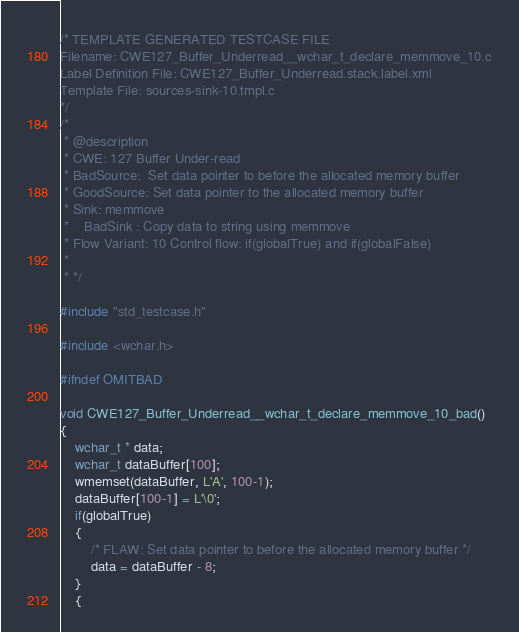Convert code to text. <code><loc_0><loc_0><loc_500><loc_500><_C_>/* TEMPLATE GENERATED TESTCASE FILE
Filename: CWE127_Buffer_Underread__wchar_t_declare_memmove_10.c
Label Definition File: CWE127_Buffer_Underread.stack.label.xml
Template File: sources-sink-10.tmpl.c
*/
/*
 * @description
 * CWE: 127 Buffer Under-read
 * BadSource:  Set data pointer to before the allocated memory buffer
 * GoodSource: Set data pointer to the allocated memory buffer
 * Sink: memmove
 *    BadSink : Copy data to string using memmove
 * Flow Variant: 10 Control flow: if(globalTrue) and if(globalFalse)
 *
 * */

#include "std_testcase.h"

#include <wchar.h>

#ifndef OMITBAD

void CWE127_Buffer_Underread__wchar_t_declare_memmove_10_bad()
{
    wchar_t * data;
    wchar_t dataBuffer[100];
    wmemset(dataBuffer, L'A', 100-1);
    dataBuffer[100-1] = L'\0';
    if(globalTrue)
    {
        /* FLAW: Set data pointer to before the allocated memory buffer */
        data = dataBuffer - 8;
    }
    {</code> 